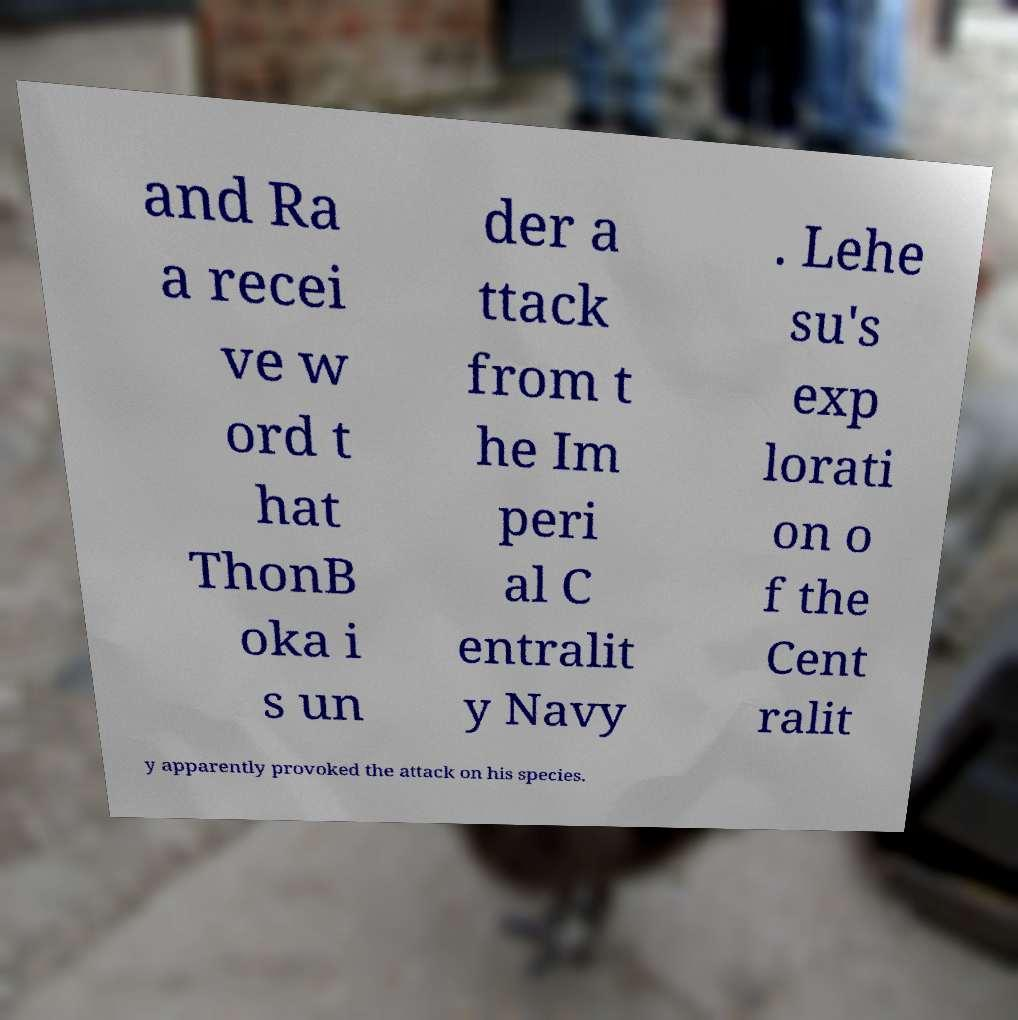Could you extract and type out the text from this image? and Ra a recei ve w ord t hat ThonB oka i s un der a ttack from t he Im peri al C entralit y Navy . Lehe su's exp lorati on o f the Cent ralit y apparently provoked the attack on his species. 